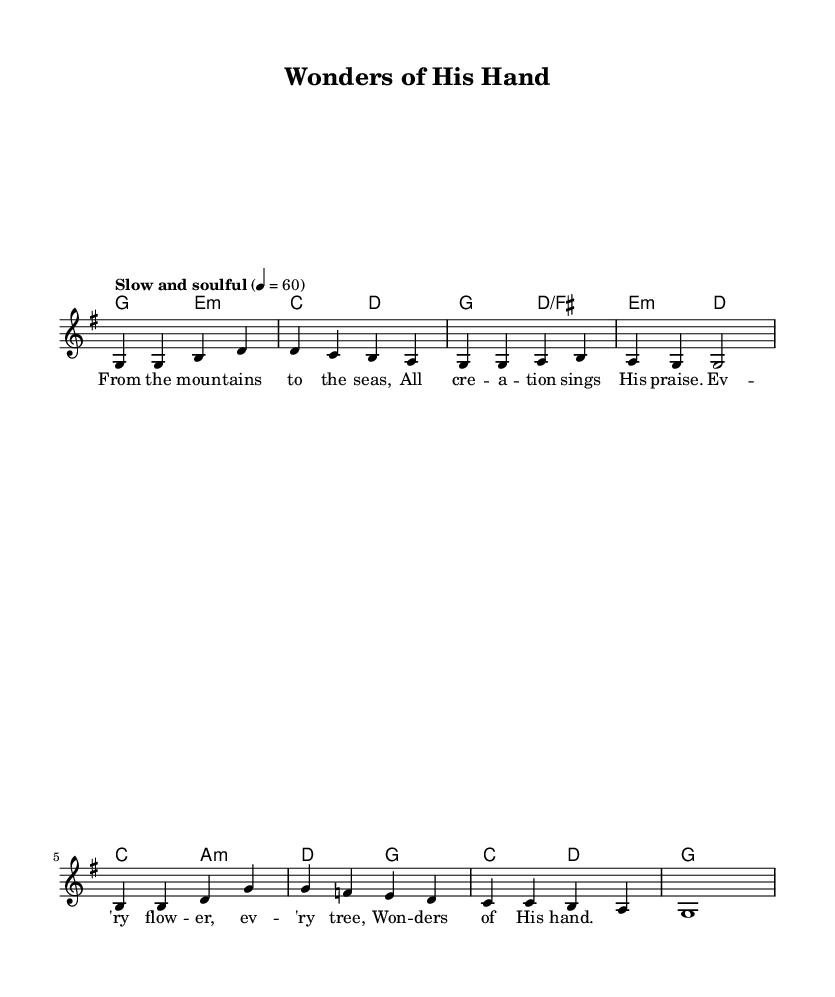What is the key signature of this music? The key signature is G major, which has one sharp (F#). This can be determined from the global section indicating "g \major".
Answer: G major What is the time signature of this music? The time signature is 4/4, indicated in the global section as "\time 4/4". This means there are four beats in a measure.
Answer: 4/4 What is the tempo marking given for this piece? The tempo marking is "Slow and soulful", which suggests a relaxed and expressive pace for the performance. This is found in the global section of the code.
Answer: Slow and soulful How many measures are in the melody section? There are eight measures in the melody section, counted by the vertical lines that indicate the end of each measure in the melody notation.
Answer: 8 What is the first lyric line of the song? The first lyric line is "From the mountains to the seas," which is indicated under the melody notes in the verse section.
Answer: From the mountains to the seas What is the purpose of the ChordNames section in the music? The ChordNames section provides the harmonic structure for the piece, indicating the chords that accompany the melody. This helps musicians understand the harmonic context while playing the melody.
Answer: To provide harmonic structure What type of music does this sheet represent? This sheet represents a religious or gospel hymn, as indicated by the theme of praising God's creation, a common characteristic in such music.
Answer: Religious or gospel hymn 